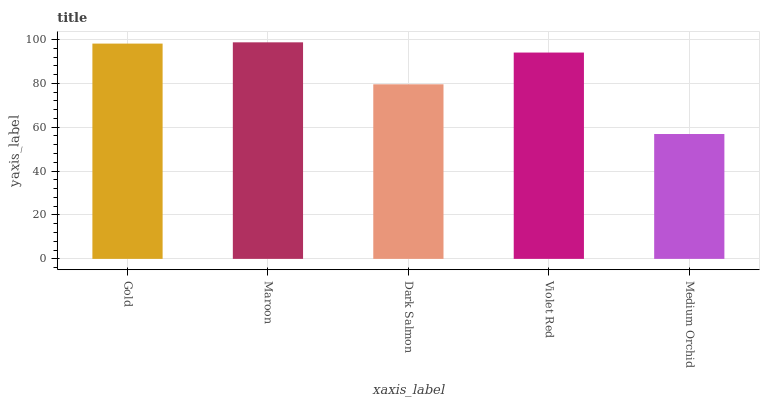Is Medium Orchid the minimum?
Answer yes or no. Yes. Is Maroon the maximum?
Answer yes or no. Yes. Is Dark Salmon the minimum?
Answer yes or no. No. Is Dark Salmon the maximum?
Answer yes or no. No. Is Maroon greater than Dark Salmon?
Answer yes or no. Yes. Is Dark Salmon less than Maroon?
Answer yes or no. Yes. Is Dark Salmon greater than Maroon?
Answer yes or no. No. Is Maroon less than Dark Salmon?
Answer yes or no. No. Is Violet Red the high median?
Answer yes or no. Yes. Is Violet Red the low median?
Answer yes or no. Yes. Is Gold the high median?
Answer yes or no. No. Is Dark Salmon the low median?
Answer yes or no. No. 